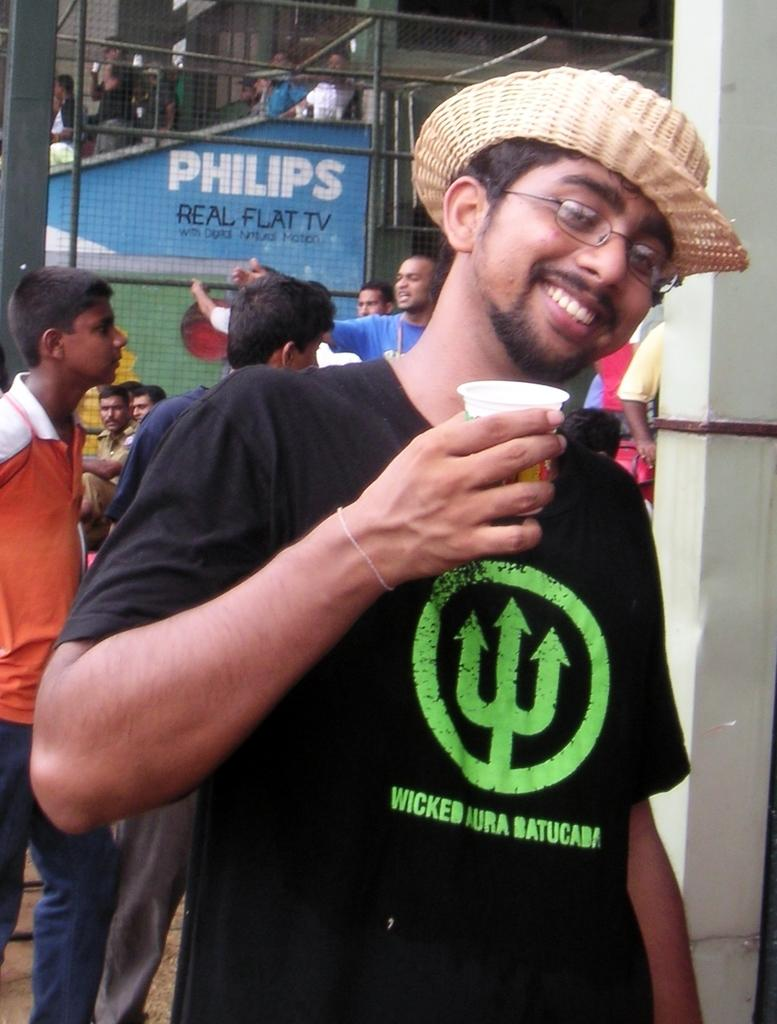What is the man in the image holding? The man is holding a cup. What is the man's facial expression in the image? The man is smiling. What accessories is the man wearing in the image? The man is wearing spectacles and a hat. What can be seen in the background of the image? There are pillars, poles, a mesh, a board, and people in the background of the image. Where is the library located in the image? There is no library present in the image. What type of doll is the man holding in the image? There is no doll present in the image; the man is holding a cup. What is the man using the hammer for in the image? There is no hammer present in the image. 